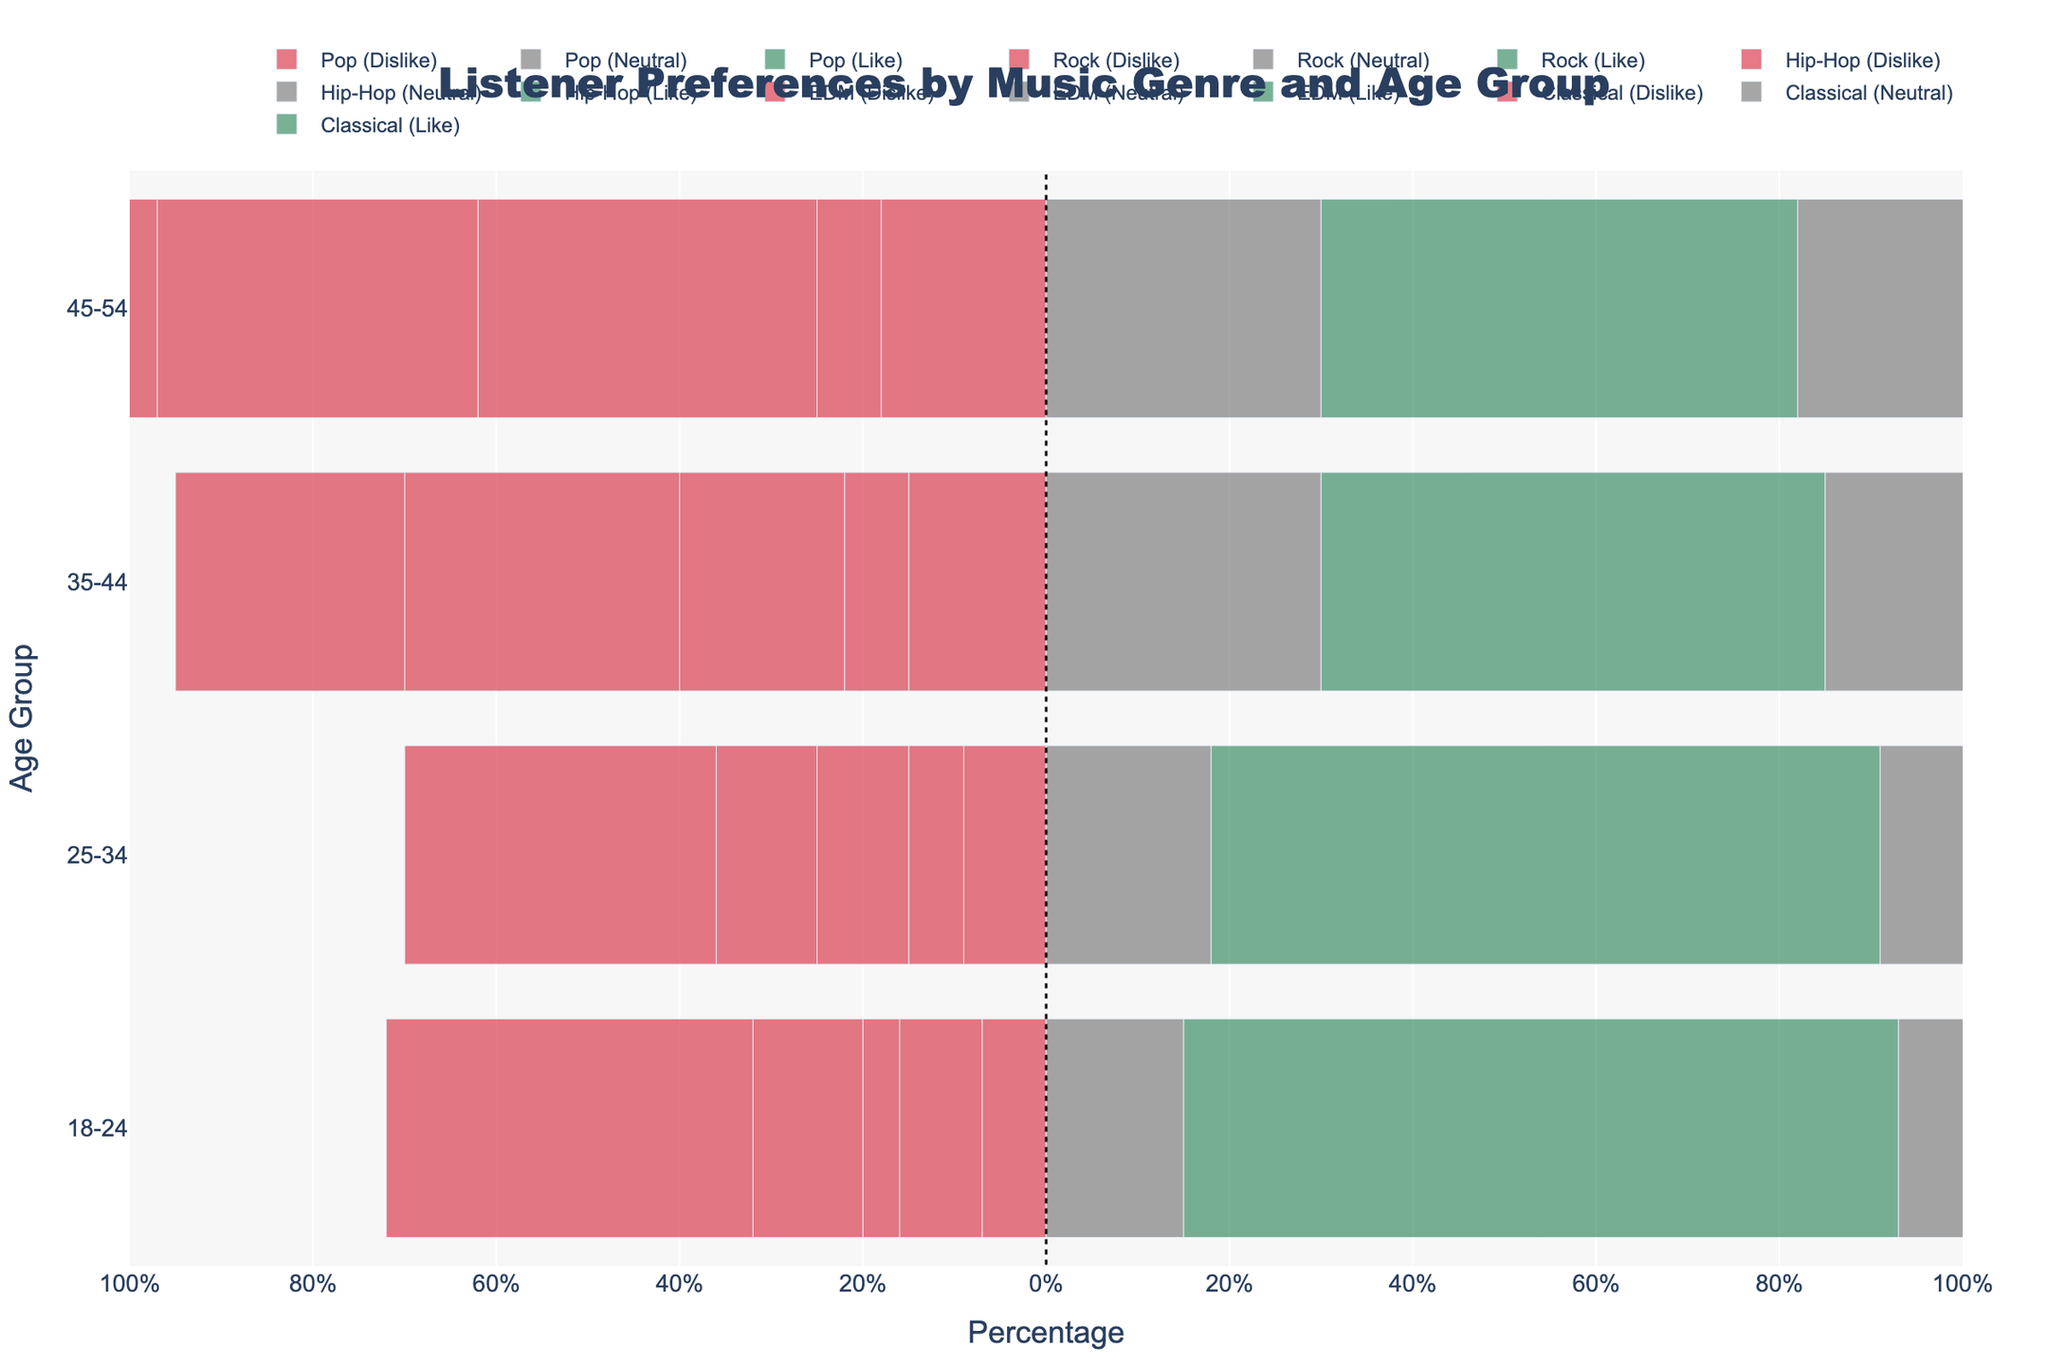Which age group likes Hip-Hop the most? Looking at the green bars representing "Like" and "Strongly Like" for Hip-Hop across different age groups, the 18-24 age group has the longest green bar, indicating the highest combined preference.
Answer: 18-24 What is the combined percentage of people in the 25-34 age group who dislike Classical music? For Classical music in the 25-34 age group, add the values of "Strongly Dislike" (14) and "Dislike" (20). (14 + 20 = 34%)
Answer: 34% How do the preferences for EDM compare between the 35-44 and 45-54 age groups? For EDM in the 35-44 age group, the "Like" and "Strongly Like" segments total 23+22=45%. In the 45-54 age group, these segments total 20+20=40%. Thus, the 35-44 age group shows a 5 percentage points higher preference for EDM.
Answer: 35-44 group likes EDM more by 5 percentage points Which music genre has the highest neutral response in the 35-44 age group? Examining the gray bars labeled "Neutral" for the 35-44 age group across all music genres, the longest gray bar is for Pop with a neutral response of 30%.
Answer: Pop How does the level of strong dislike for Pop differ between the 18-24 and 35-44 age groups? The "Strongly Dislike" value for Pop is 2% for the 18-24 age group and 5% for the 35-44 age group. Therefore, the 35-44 group has a 3 percentage points higher "Strongly Dislike" level for Pop.
Answer: 3 percentage points higher What is the most preferred genre among the 25-34 age group? Observing the green bars for "Like" and "Strongly Like" among the 25-34 age group, Rock has the highest combined percentage in these categories with a total of 36 + 44 = 80%.
Answer: Rock Which age group has the least strong negative response (Strongly Dislike + Dislike) for Hip-Hop? By adding the "Strongly Dislike" and "Dislike" values for Hip-Hop across the different age groups: 18-24 (1+3=4%), 25-34 (3+7=10%), 35-44 (6+12=18%), 45-54 (12+25=37%). The 18-24 age group has the least strong negative response with 4%.
Answer: 18-24 What percentage of the 45-54 age group strongly likes Classical music? For Classical music in the 45-54 age group, the "Strongly Like" bar represents 24%.
Answer: 24% Compare the total preferability ("Like" + "Strongly Like") for Rock between the 18-24 and 25-34 age groups. For the 18-24 age group, "Like" + "Strongly Like" for Rock is 40 + 31 = 71%. For the 25-34 age group, it is 36 + 44 = 80%. Therefore, the 25-34 group prefers Rock by 9 percentage points more.
Answer: 9 percentage points more Which genre is least liked by the 18-24 age group? Evaluating the combined "Strongly Dislike" and "Dislike" percentages for the 18-24 age group across all genres: Pop (2+5=7%), Rock (3+6=9%), Hip-Hop (1+3=4%), EDM (4+8=12%), Classical (15+25=40%). Classical is the least liked with 40%.
Answer: Classical 